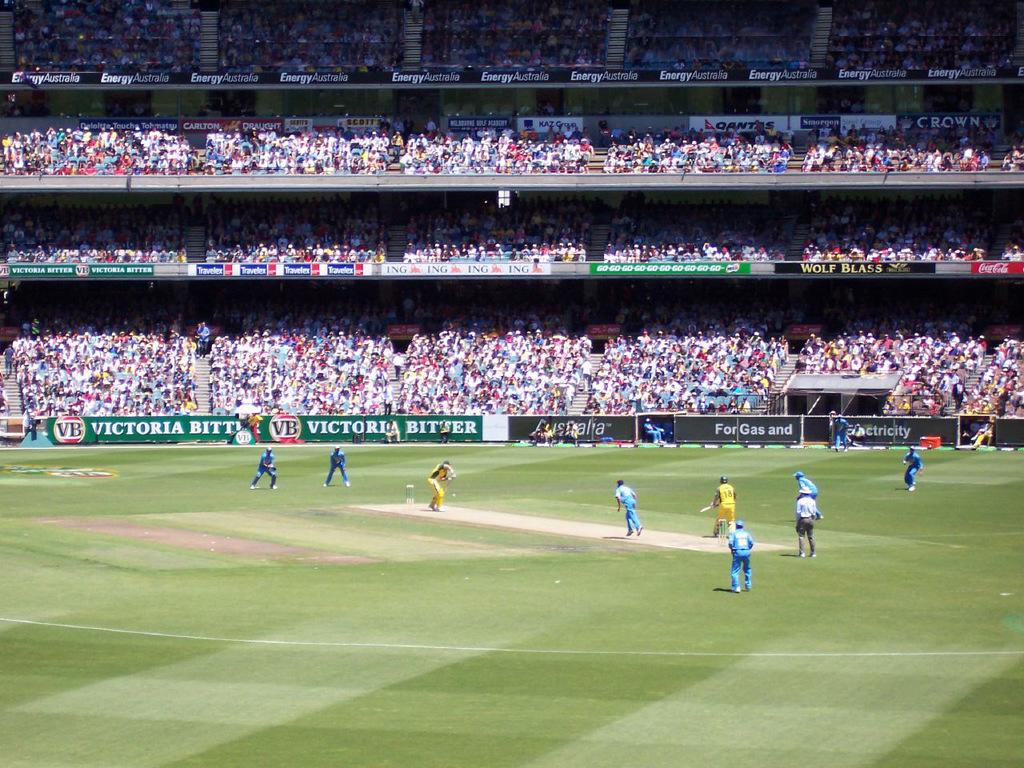What sport are the people playing in the image? The people are playing cricket in the image. Where is the cricket game taking place? The cricket game is taking place on a ground. What can be seen on the walls or structures in the image? There are posters in the image. What architectural feature is visible in the image? There are steps in the image. What else is present in the image besides the people playing cricket? There are objects and a group of people in the image. What type of letter is being written by the car in the image? There is no car present in the image, and therefore no letter-writing activity can be observed. 